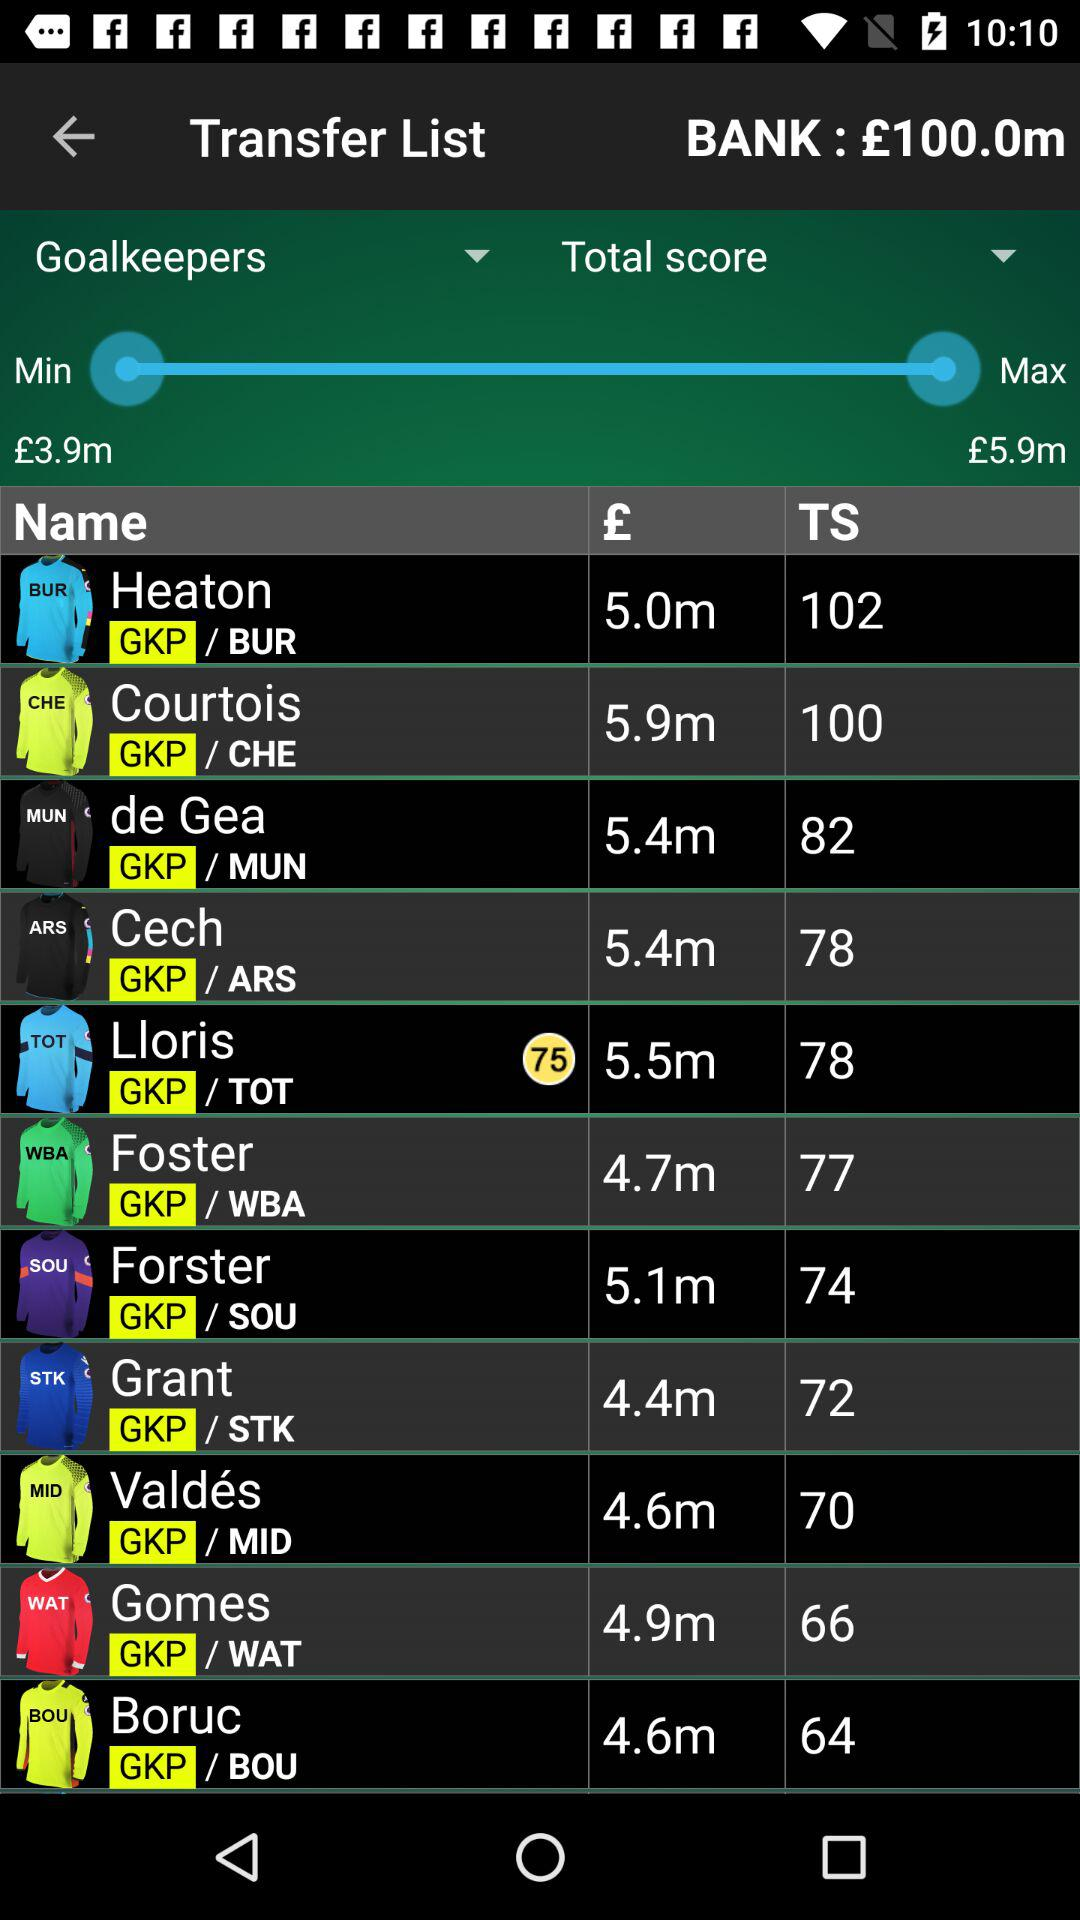What is the currency of the amount? The currency of the amount is £. 